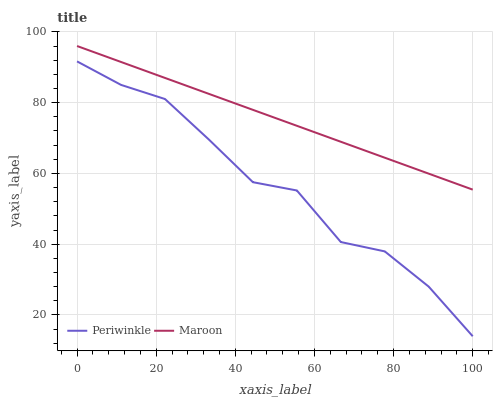Does Periwinkle have the minimum area under the curve?
Answer yes or no. Yes. Does Maroon have the maximum area under the curve?
Answer yes or no. Yes. Does Maroon have the minimum area under the curve?
Answer yes or no. No. Is Maroon the smoothest?
Answer yes or no. Yes. Is Periwinkle the roughest?
Answer yes or no. Yes. Is Maroon the roughest?
Answer yes or no. No. Does Periwinkle have the lowest value?
Answer yes or no. Yes. Does Maroon have the lowest value?
Answer yes or no. No. Does Maroon have the highest value?
Answer yes or no. Yes. Is Periwinkle less than Maroon?
Answer yes or no. Yes. Is Maroon greater than Periwinkle?
Answer yes or no. Yes. Does Periwinkle intersect Maroon?
Answer yes or no. No. 